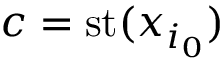Convert formula to latex. <formula><loc_0><loc_0><loc_500><loc_500>c = { s t } ( x _ { i _ { 0 } } )</formula> 